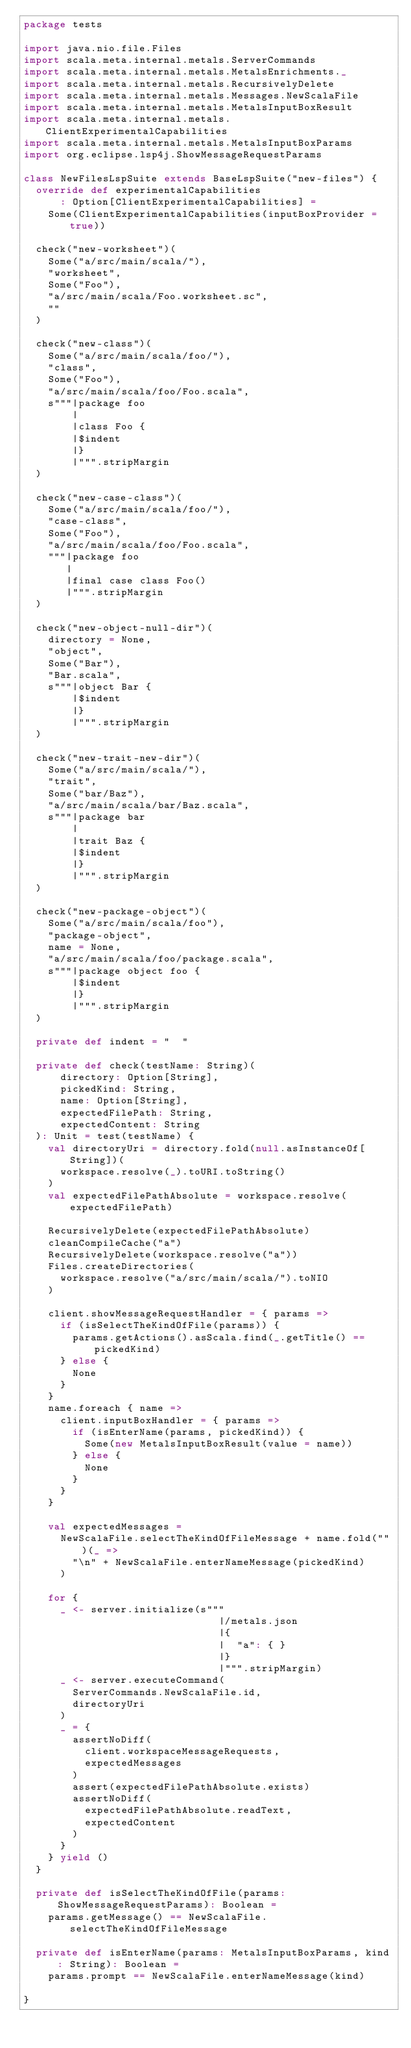<code> <loc_0><loc_0><loc_500><loc_500><_Scala_>package tests

import java.nio.file.Files
import scala.meta.internal.metals.ServerCommands
import scala.meta.internal.metals.MetalsEnrichments._
import scala.meta.internal.metals.RecursivelyDelete
import scala.meta.internal.metals.Messages.NewScalaFile
import scala.meta.internal.metals.MetalsInputBoxResult
import scala.meta.internal.metals.ClientExperimentalCapabilities
import scala.meta.internal.metals.MetalsInputBoxParams
import org.eclipse.lsp4j.ShowMessageRequestParams

class NewFilesLspSuite extends BaseLspSuite("new-files") {
  override def experimentalCapabilities
      : Option[ClientExperimentalCapabilities] =
    Some(ClientExperimentalCapabilities(inputBoxProvider = true))

  check("new-worksheet")(
    Some("a/src/main/scala/"),
    "worksheet",
    Some("Foo"),
    "a/src/main/scala/Foo.worksheet.sc",
    ""
  )

  check("new-class")(
    Some("a/src/main/scala/foo/"),
    "class",
    Some("Foo"),
    "a/src/main/scala/foo/Foo.scala",
    s"""|package foo
        |
        |class Foo {
        |$indent
        |}
        |""".stripMargin
  )

  check("new-case-class")(
    Some("a/src/main/scala/foo/"),
    "case-class",
    Some("Foo"),
    "a/src/main/scala/foo/Foo.scala",
    """|package foo
       |
       |final case class Foo()
       |""".stripMargin
  )

  check("new-object-null-dir")(
    directory = None,
    "object",
    Some("Bar"),
    "Bar.scala",
    s"""|object Bar {
        |$indent
        |}
        |""".stripMargin
  )

  check("new-trait-new-dir")(
    Some("a/src/main/scala/"),
    "trait",
    Some("bar/Baz"),
    "a/src/main/scala/bar/Baz.scala",
    s"""|package bar
        |
        |trait Baz {
        |$indent
        |}
        |""".stripMargin
  )

  check("new-package-object")(
    Some("a/src/main/scala/foo"),
    "package-object",
    name = None,
    "a/src/main/scala/foo/package.scala",
    s"""|package object foo {
        |$indent
        |}
        |""".stripMargin
  )

  private def indent = "  "

  private def check(testName: String)(
      directory: Option[String],
      pickedKind: String,
      name: Option[String],
      expectedFilePath: String,
      expectedContent: String
  ): Unit = test(testName) {
    val directoryUri = directory.fold(null.asInstanceOf[String])(
      workspace.resolve(_).toURI.toString()
    )
    val expectedFilePathAbsolute = workspace.resolve(expectedFilePath)

    RecursivelyDelete(expectedFilePathAbsolute)
    cleanCompileCache("a")
    RecursivelyDelete(workspace.resolve("a"))
    Files.createDirectories(
      workspace.resolve("a/src/main/scala/").toNIO
    )

    client.showMessageRequestHandler = { params =>
      if (isSelectTheKindOfFile(params)) {
        params.getActions().asScala.find(_.getTitle() == pickedKind)
      } else {
        None
      }
    }
    name.foreach { name =>
      client.inputBoxHandler = { params =>
        if (isEnterName(params, pickedKind)) {
          Some(new MetalsInputBoxResult(value = name))
        } else {
          None
        }
      }
    }

    val expectedMessages =
      NewScalaFile.selectTheKindOfFileMessage + name.fold("")(_ =>
        "\n" + NewScalaFile.enterNameMessage(pickedKind)
      )

    for {
      _ <- server.initialize(s"""
                                |/metals.json
                                |{
                                |  "a": { }
                                |}
                                |""".stripMargin)
      _ <- server.executeCommand(
        ServerCommands.NewScalaFile.id,
        directoryUri
      )
      _ = {
        assertNoDiff(
          client.workspaceMessageRequests,
          expectedMessages
        )
        assert(expectedFilePathAbsolute.exists)
        assertNoDiff(
          expectedFilePathAbsolute.readText,
          expectedContent
        )
      }
    } yield ()
  }

  private def isSelectTheKindOfFile(params: ShowMessageRequestParams): Boolean =
    params.getMessage() == NewScalaFile.selectTheKindOfFileMessage

  private def isEnterName(params: MetalsInputBoxParams, kind: String): Boolean =
    params.prompt == NewScalaFile.enterNameMessage(kind)

}
</code> 